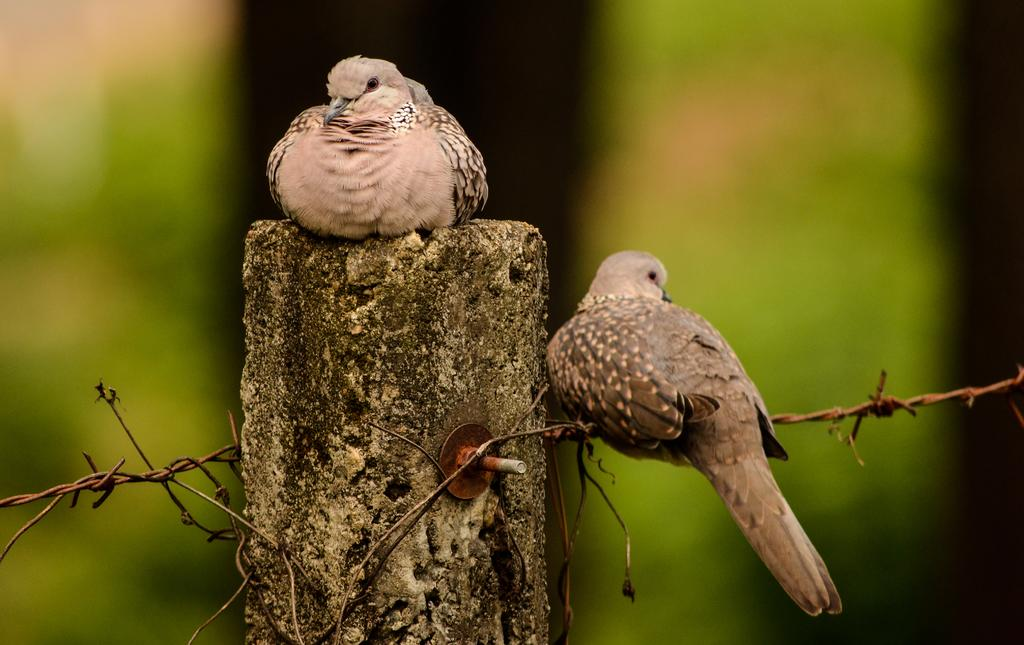What type of animals can be seen in the picture? Birds can be seen in the picture. Can you describe the location of one of the birds? One bird is sitting on a pillar. What is another location where a bird can be found in the image? Another bird is sitting on a fence. How many apples are being rolled by the birds in the image? There are no apples present in the image, and the birds are not rolling anything. 